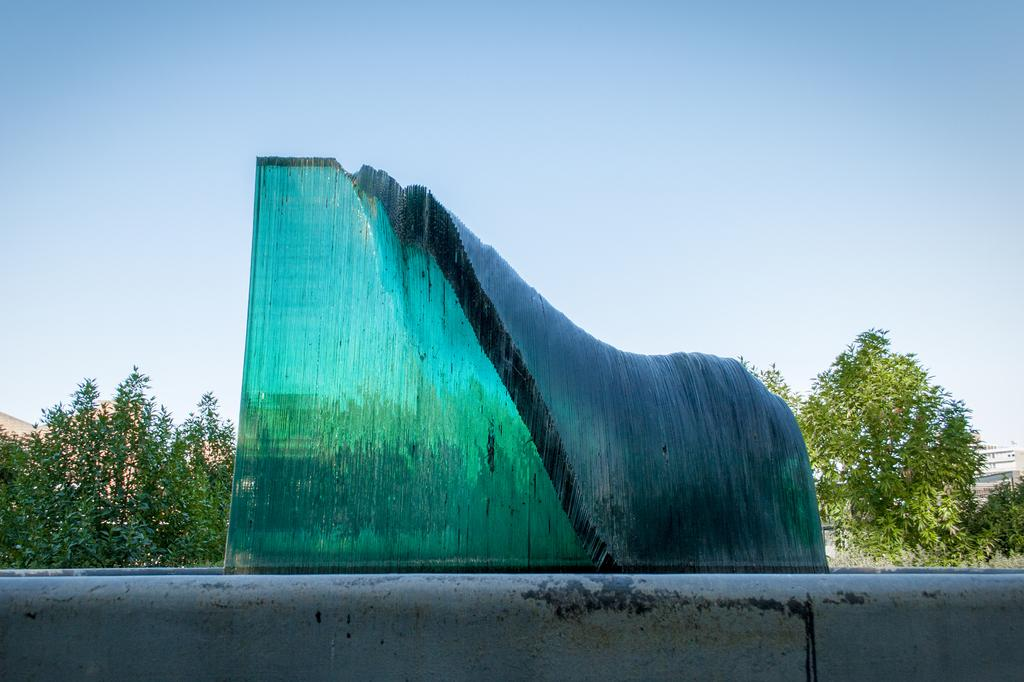What type of artwork is on the wall in the image? There is a glass sculpture on the wall in the image. What can be seen behind the glass sculpture? There are many trees visible behind the glass sculpture. What arithmetic problem is being solved by the beast in the image? There is no beast or arithmetic problem present in the image. 